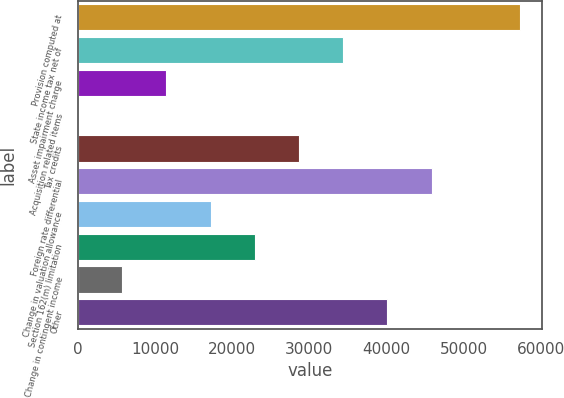<chart> <loc_0><loc_0><loc_500><loc_500><bar_chart><fcel>Provision computed at<fcel>State income tax net of<fcel>Asset impairment charge<fcel>Acquisition related items<fcel>Tax credits<fcel>Foreign rate differential<fcel>Change in valuation allowance<fcel>Section 162(m) limitation<fcel>Change in contingent income<fcel>Other<nl><fcel>57339<fcel>34403.9<fcel>11468.8<fcel>1.29<fcel>28670.1<fcel>45871.4<fcel>17202.6<fcel>22936.4<fcel>5735.06<fcel>40137.7<nl></chart> 